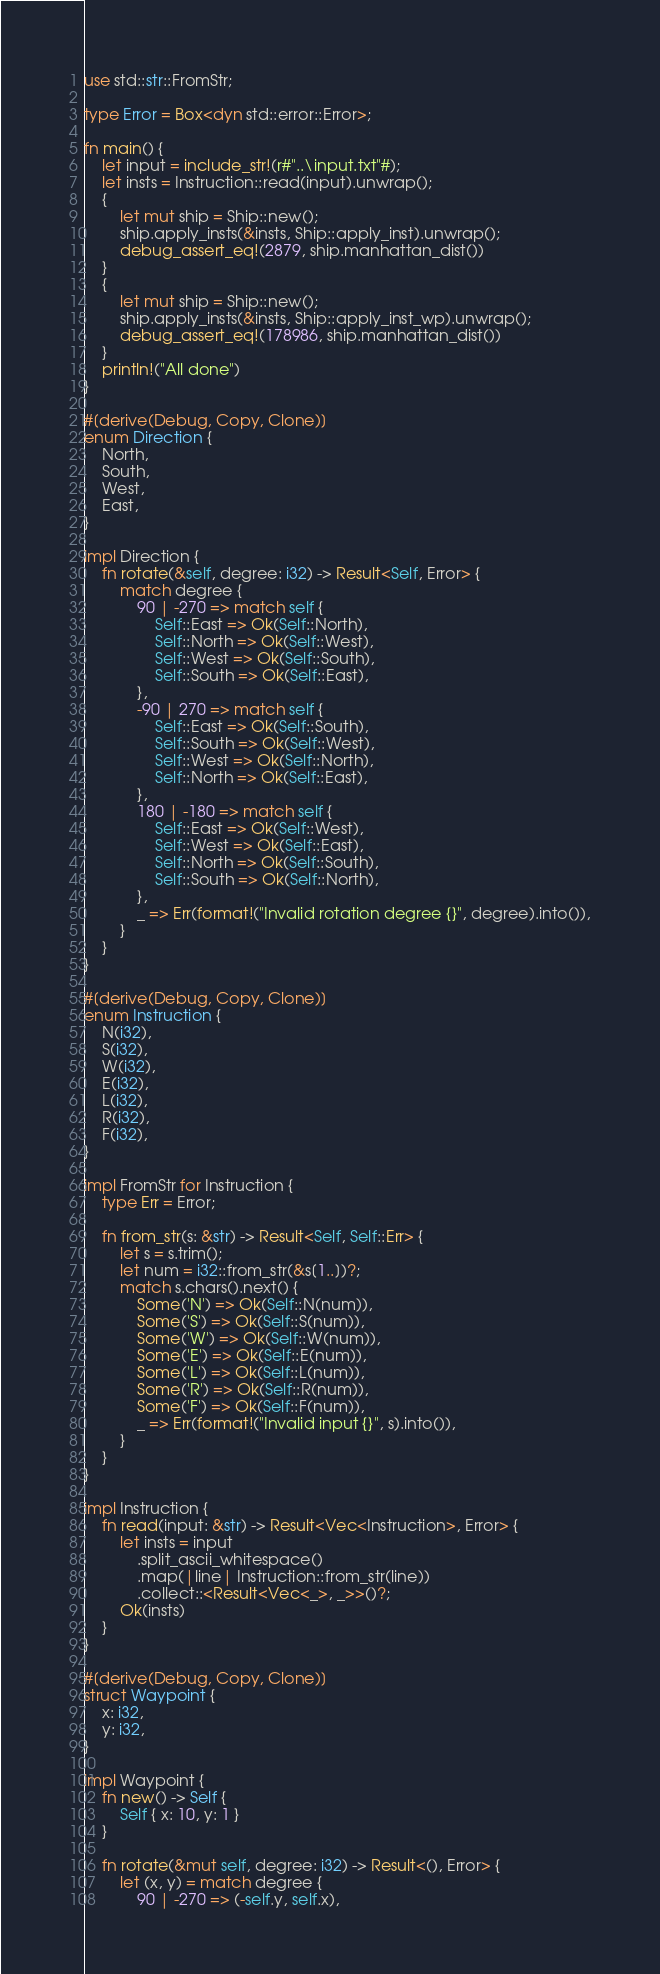<code> <loc_0><loc_0><loc_500><loc_500><_Rust_>use std::str::FromStr;

type Error = Box<dyn std::error::Error>;

fn main() {
    let input = include_str!(r#"..\input.txt"#);
    let insts = Instruction::read(input).unwrap();
    {
        let mut ship = Ship::new();
        ship.apply_insts(&insts, Ship::apply_inst).unwrap();
        debug_assert_eq!(2879, ship.manhattan_dist())
    }
    {
        let mut ship = Ship::new();
        ship.apply_insts(&insts, Ship::apply_inst_wp).unwrap();
        debug_assert_eq!(178986, ship.manhattan_dist())
    }
    println!("All done")
}

#[derive(Debug, Copy, Clone)]
enum Direction {
    North,
    South,
    West,
    East,
}

impl Direction {
    fn rotate(&self, degree: i32) -> Result<Self, Error> {
        match degree {
            90 | -270 => match self {
                Self::East => Ok(Self::North),
                Self::North => Ok(Self::West),
                Self::West => Ok(Self::South),
                Self::South => Ok(Self::East),
            },
            -90 | 270 => match self {
                Self::East => Ok(Self::South),
                Self::South => Ok(Self::West),
                Self::West => Ok(Self::North),
                Self::North => Ok(Self::East),
            },
            180 | -180 => match self {
                Self::East => Ok(Self::West),
                Self::West => Ok(Self::East),
                Self::North => Ok(Self::South),
                Self::South => Ok(Self::North),
            },
            _ => Err(format!("Invalid rotation degree {}", degree).into()),
        }
    }
}

#[derive(Debug, Copy, Clone)]
enum Instruction {
    N(i32),
    S(i32),
    W(i32),
    E(i32),
    L(i32),
    R(i32),
    F(i32),
}

impl FromStr for Instruction {
    type Err = Error;

    fn from_str(s: &str) -> Result<Self, Self::Err> {
        let s = s.trim();
        let num = i32::from_str(&s[1..])?;
        match s.chars().next() {
            Some('N') => Ok(Self::N(num)),
            Some('S') => Ok(Self::S(num)),
            Some('W') => Ok(Self::W(num)),
            Some('E') => Ok(Self::E(num)),
            Some('L') => Ok(Self::L(num)),
            Some('R') => Ok(Self::R(num)),
            Some('F') => Ok(Self::F(num)),
            _ => Err(format!("Invalid input {}", s).into()),
        }
    }
}

impl Instruction {
    fn read(input: &str) -> Result<Vec<Instruction>, Error> {
        let insts = input
            .split_ascii_whitespace()
            .map(|line| Instruction::from_str(line))
            .collect::<Result<Vec<_>, _>>()?;
        Ok(insts)
    }
}

#[derive(Debug, Copy, Clone)]
struct Waypoint {
    x: i32,
    y: i32,
}

impl Waypoint {
    fn new() -> Self {
        Self { x: 10, y: 1 }
    }

    fn rotate(&mut self, degree: i32) -> Result<(), Error> {
        let (x, y) = match degree {
            90 | -270 => (-self.y, self.x),</code> 